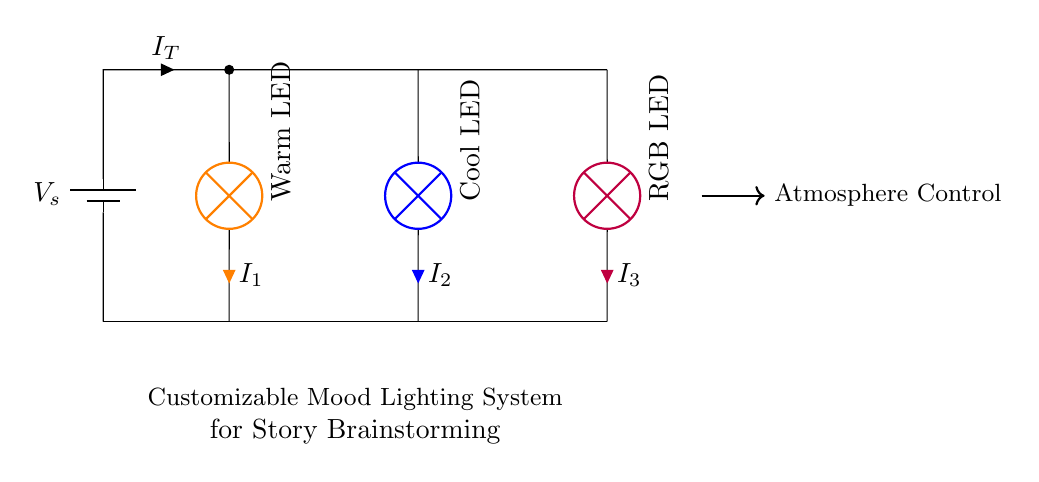What is the total current flowing through the circuit? The total current, \( I_T \), sums the currents through each lamp. In a parallel circuit, the current divides among the branches. However, without specific values for \( I_1, I_2, \) and \( I_3 \), we cannot calculate a numerical answer. The answer depends on the individual currents.
Answer: Depends on \( I_1, I_2, I_3 \) What type of lamps are used in this circuit? The circuit diagram shows three types of lamps: a warm LED, a cool LED, and an RGB LED. Each lamp is labeled with its respective type, indicating the light colors they emit.
Answer: Warm LED, Cool LED, RGB LED Which lamp would provide a cooler atmosphere for brainstorming? The cool LED, which is blue, would typically be associated with a cooler atmosphere as compared to warmer colors, which are more comforting and cozy.
Answer: Cool LED What is the significance of the customizable mood lighting system? The customizable lighting allows for the creation of various atmospheres. By adjusting the individual lamps, users can set different moods conducive to brainstorming, enhancing creativity and focus.
Answer: Enhances brainstorming atmosphere What happens if one lamp fails in this parallel circuit? In a parallel circuit, if one lamp fails, the others continue to operate because each lamp has its own branch connected to the voltage source. This characteristic allows for continued functionality.
Answer: Other lamps remain functional 